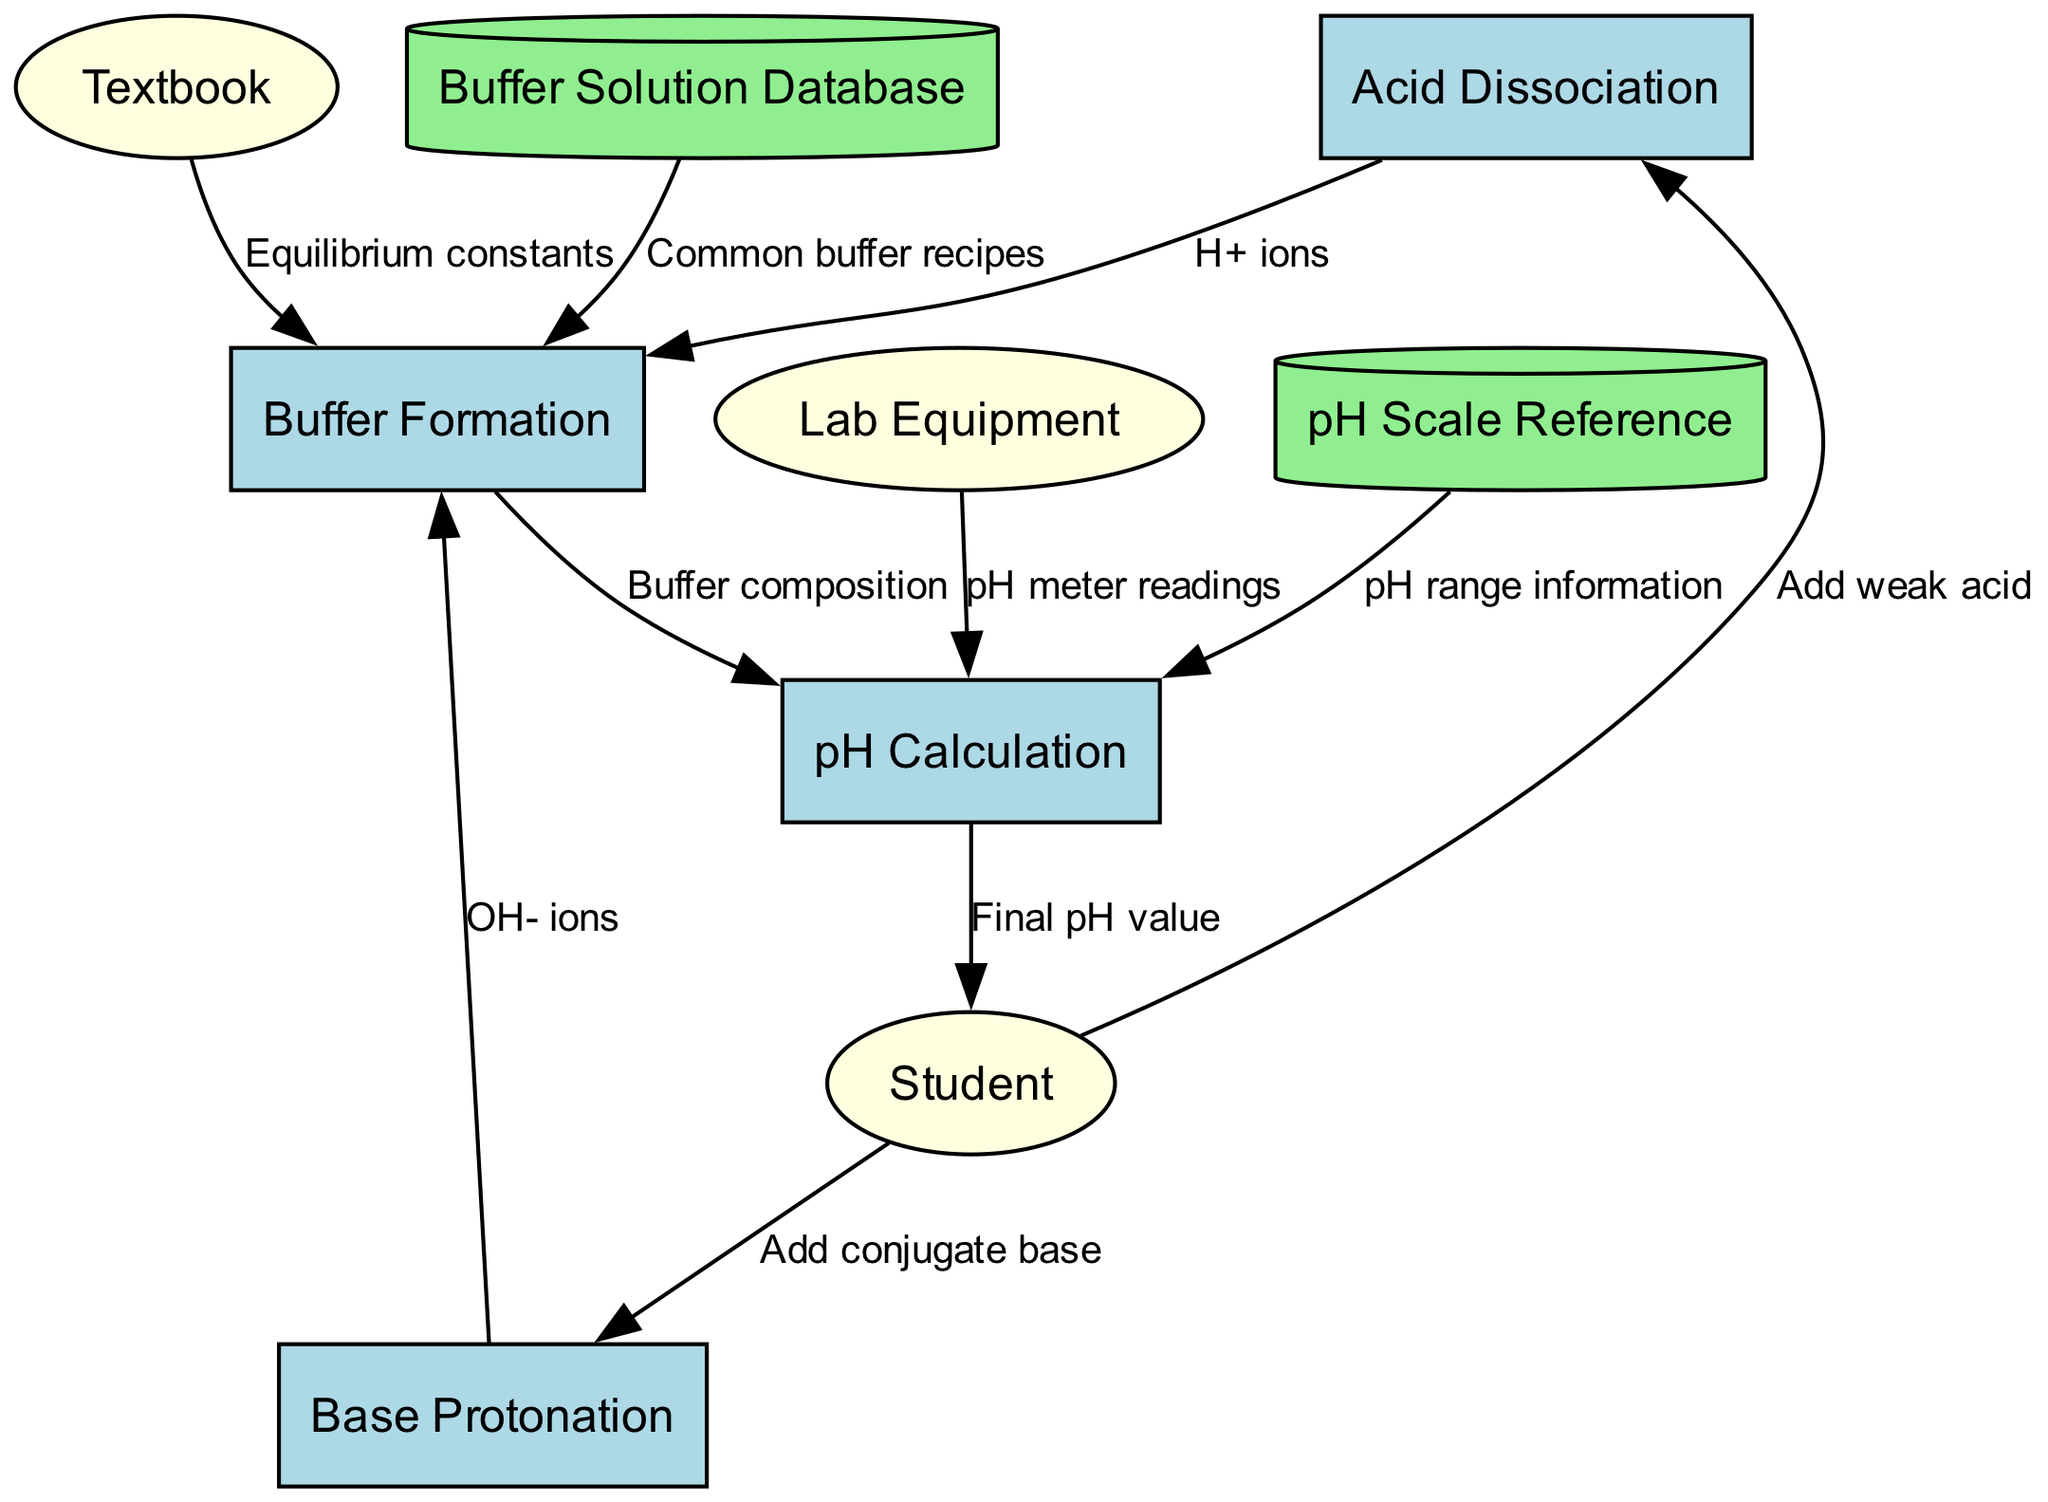What processes are involved in the chemical equilibrium of buffer solutions? The diagram lists four processes: Acid Dissociation, Base Protonation, Buffer Formation, and pH Calculation. These are shown as different nodes connected to one another, indicating their relationships and order in the chemical equilibrium context of buffer solutions.
Answer: Acid Dissociation, Base Protonation, Buffer Formation, pH Calculation Which external entity adds a weak acid to the process? The diagram shows that the Student is the external entity that adds a weak acid. This is represented as a flow from the Student node to the Acid Dissociation node, signifying the action explicitly.
Answer: Student How many data stores are present in the diagram? The diagram lists two data stores: Buffer Solution Database and pH Scale Reference. Counting these nodes provides the total number of data stores in the diagram.
Answer: 2 What is the flow label between Buffer Formation and pH Calculation? The flow labeled between Buffer Formation and pH Calculation indicates "Buffer composition." This label describes the data flow from one process to the next, specifying what is being transferred.
Answer: Buffer composition What does the Lab Equipment provide for pH Calculation? According to the diagram, Lab Equipment provides pH meter readings for the pH Calculation process. This relationship is indicated by a directed flow from the Lab Equipment node to the pH Calculation node.
Answer: pH meter readings How does the Buffer Solution Database contribute to Buffer Formation? The Buffer Solution Database contributes by providing common buffer recipes to the Buffer Formation process. This connection is represented by a flow marked with this specific labeling in the diagram.
Answer: Common buffer recipes Which process receives the final pH value? The diagram shows that the Student receives the final pH value after the pH Calculation process. This is indicated by the directed flow from pH Calculation to the Student, highlighting the output of the process.
Answer: Student What input does Base Protonation accept from the Student? The flow diagram indicates that the Base Protonation process accepts the addition of a conjugate base from the Student. This is shown as a flow directed specifically from the Student to the Base Protonation node.
Answer: Add conjugate base What information source does Buffer Formation draw from? The Buffer Formation process draws information from two sources: the textbook for equilibrium constants and the Buffer Solution Database for common recipes. Both inputs are indicated by directed flows coming into the Buffer Formation node.
Answer: Equilibrium constants, Common buffer recipes 